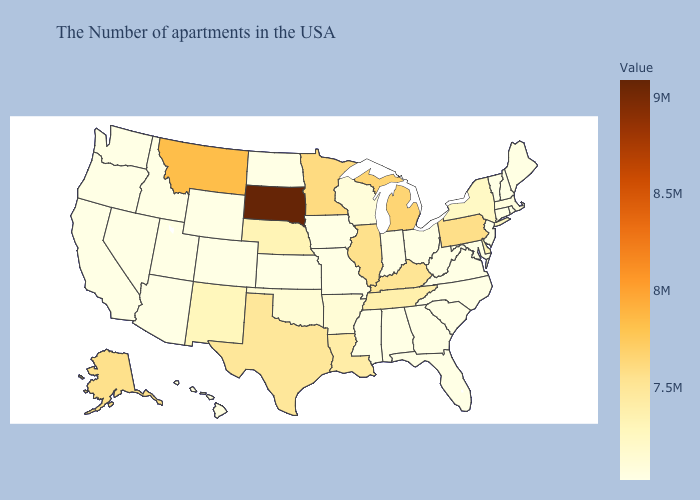Does South Dakota have the highest value in the USA?
Quick response, please. Yes. Among the states that border South Carolina , which have the highest value?
Be succinct. North Carolina, Georgia. Which states have the lowest value in the USA?
Answer briefly. Rhode Island, New Hampshire, Vermont, Connecticut, New Jersey, Maryland, Virginia, North Carolina, South Carolina, West Virginia, Ohio, Florida, Georgia, Indiana, Alabama, Mississippi, Missouri, Iowa, Kansas, North Dakota, Wyoming, Colorado, Utah, Arizona, Idaho, Nevada, California, Washington, Oregon. Among the states that border Nebraska , which have the lowest value?
Answer briefly. Missouri, Iowa, Kansas, Wyoming, Colorado. Does Alaska have a higher value than Oklahoma?
Be succinct. Yes. Does South Dakota have the highest value in the USA?
Concise answer only. Yes. 